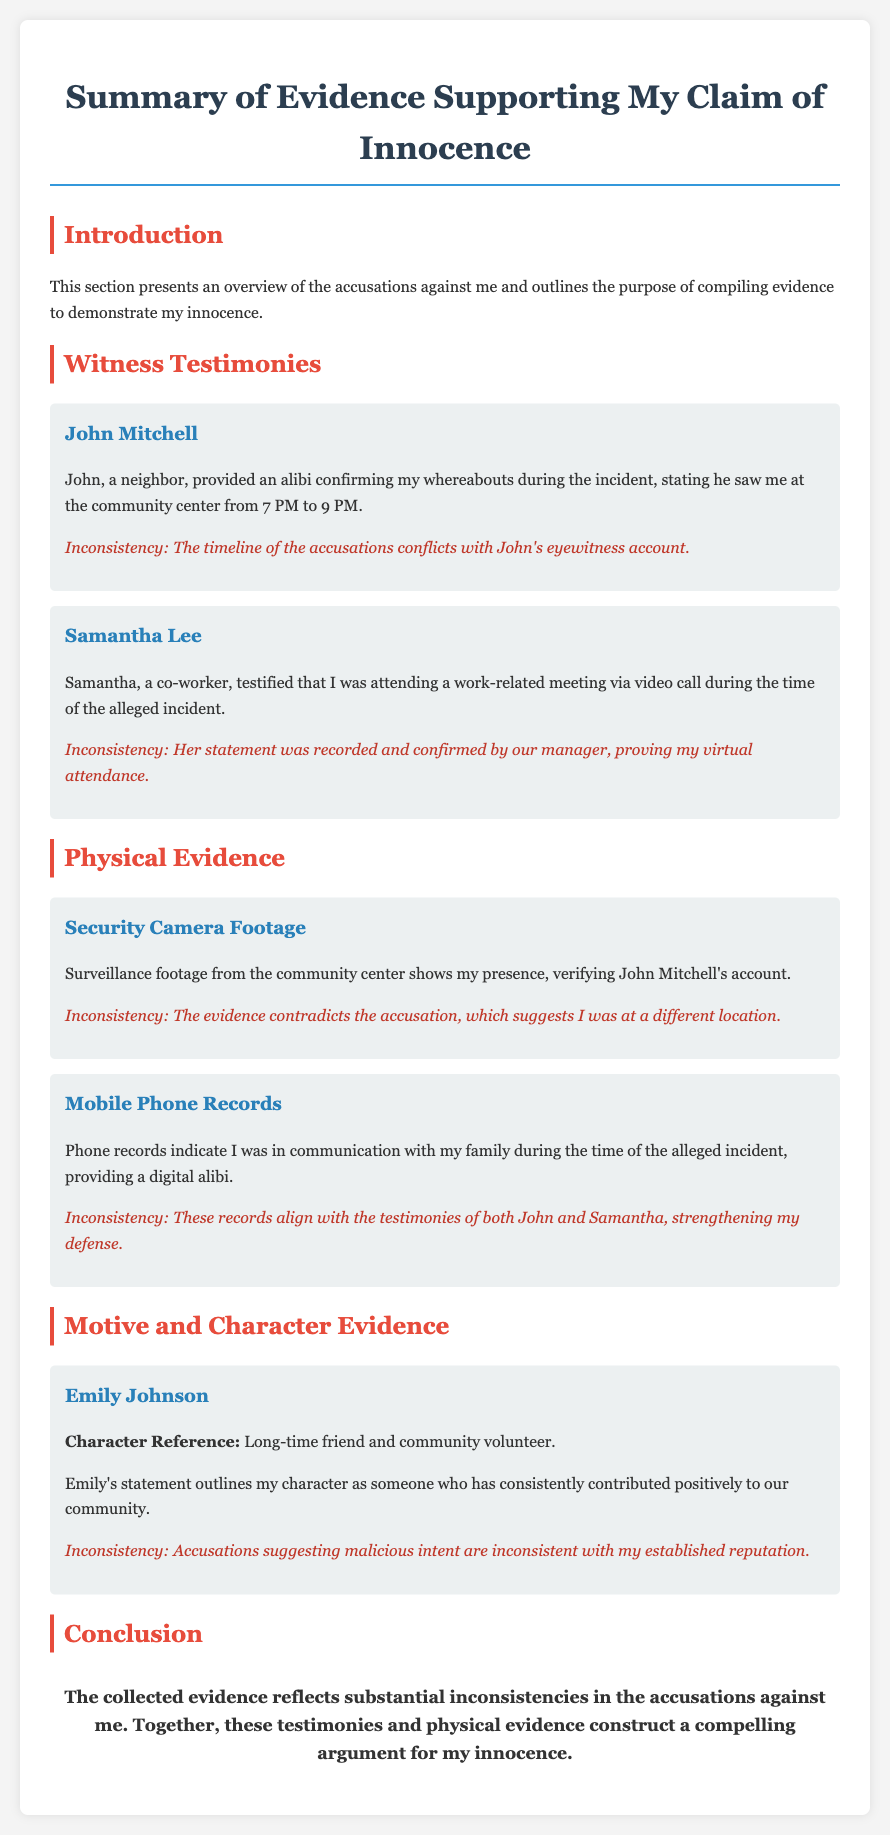What is the name of the first witness? The first witness mentioned in the document is John Mitchell, who provided an alibi confirming the author's whereabouts.
Answer: John Mitchell What was John Mitchell's alibi? John Mitchell testified that he saw the author at the community center from 7 PM to 9 PM, which serves as an alibi for the author during the incident.
Answer: Community center from 7 PM to 9 PM What evidence supports the author's claim of innocence? The evidence includes security camera footage from the community center, which shows the author’s presence during the incident.
Answer: Security camera footage Who confirmed the virtual attendance of the author during the alleged incident? Samantha Lee, a co-worker, testified to the author’s attendance via video call during the time of the alleged incident.
Answer: Samantha Lee What does the mobile phone records indicate? Mobile phone records indicate that the author was in communication with family during the time of the incident, providing a digital alibi.
Answer: Communication with family What is Emily Johnson's relationship to the author? Emily Johnson is described as a long-time friend and community volunteer who provides a character reference for the author.
Answer: Long-time friend What inconsistency does the document highlight regarding the accusations? The document highlights that the accusations suggesting malicious intent are inconsistent with the author's established reputation.
Answer: Malicious intent How does the conclusion summarize the gathered evidence? The conclusion states that the collected evidence reflects substantial inconsistencies in the accusations, constructing a compelling argument for the author's innocence.
Answer: Substantial inconsistencies What is the purpose of compiling evidence in this document? The purpose outlined in the document is to demonstrate the author's innocence against the accusations made.
Answer: Demonstrate innocence 